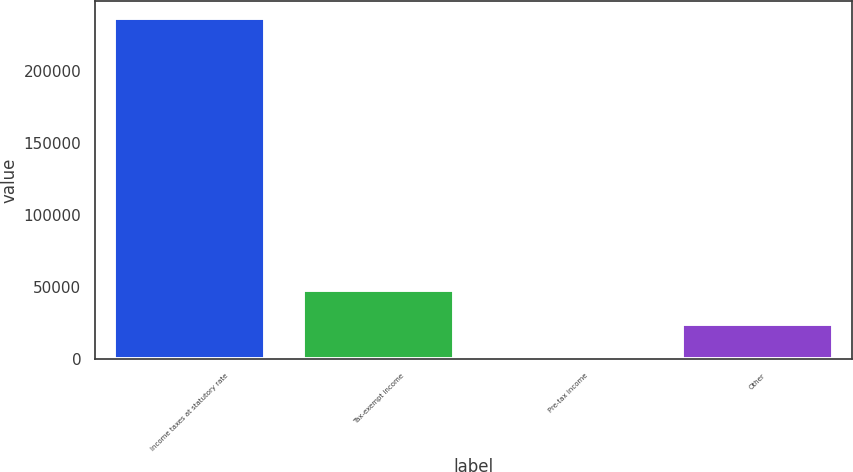<chart> <loc_0><loc_0><loc_500><loc_500><bar_chart><fcel>Income taxes at statutory rate<fcel>Tax-exempt income<fcel>Pre-tax income<fcel>Other<nl><fcel>236567<fcel>48006.2<fcel>866<fcel>24436.1<nl></chart> 